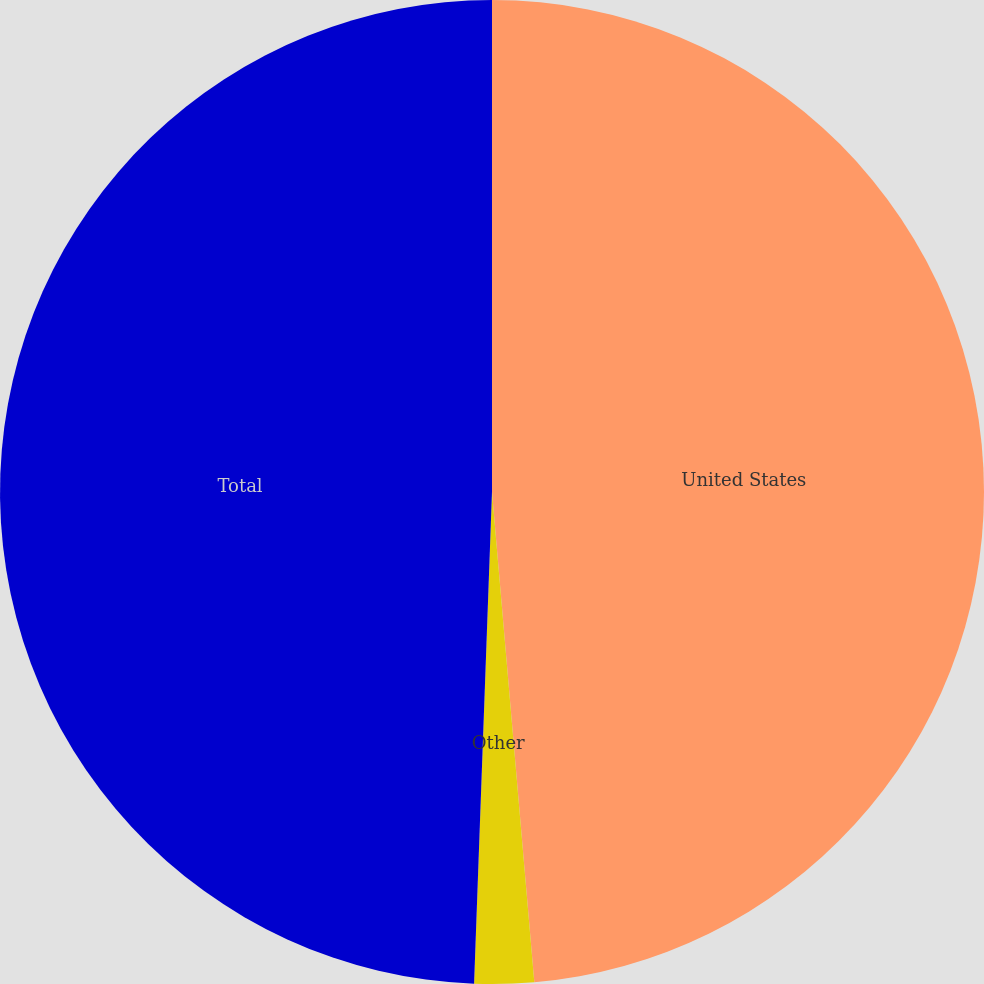Convert chart to OTSL. <chart><loc_0><loc_0><loc_500><loc_500><pie_chart><fcel>United States<fcel>Other<fcel>Total<nl><fcel>48.63%<fcel>1.95%<fcel>49.42%<nl></chart> 